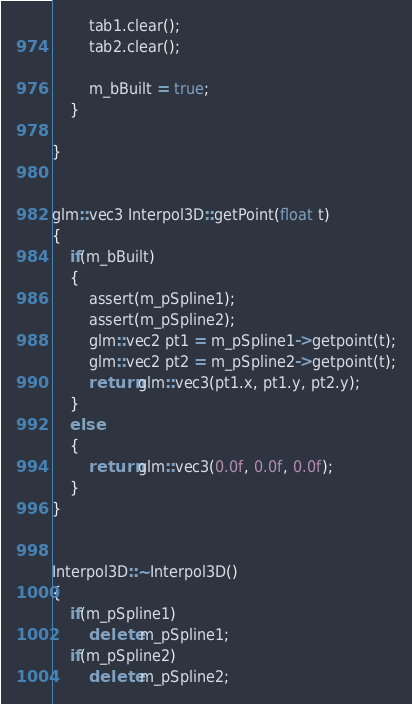Convert code to text. <code><loc_0><loc_0><loc_500><loc_500><_C++_>

        tab1.clear();
        tab2.clear();

        m_bBuilt = true;
    }

}


glm::vec3 Interpol3D::getPoint(float t)
{
    if(m_bBuilt)
    {
        assert(m_pSpline1);
        assert(m_pSpline2);
        glm::vec2 pt1 = m_pSpline1->getpoint(t);
        glm::vec2 pt2 = m_pSpline2->getpoint(t);
        return glm::vec3(pt1.x, pt1.y, pt2.y);
    }
    else
    {
        return glm::vec3(0.0f, 0.0f, 0.0f);
    }
}


Interpol3D::~Interpol3D()
{
    if(m_pSpline1)
        delete m_pSpline1;
    if(m_pSpline2)
        delete m_pSpline2;</code> 